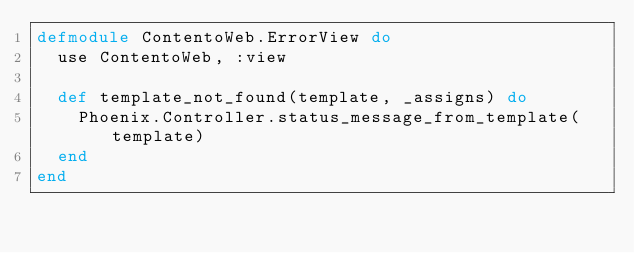<code> <loc_0><loc_0><loc_500><loc_500><_Elixir_>defmodule ContentoWeb.ErrorView do
  use ContentoWeb, :view

  def template_not_found(template, _assigns) do
    Phoenix.Controller.status_message_from_template(template)
  end
end
</code> 